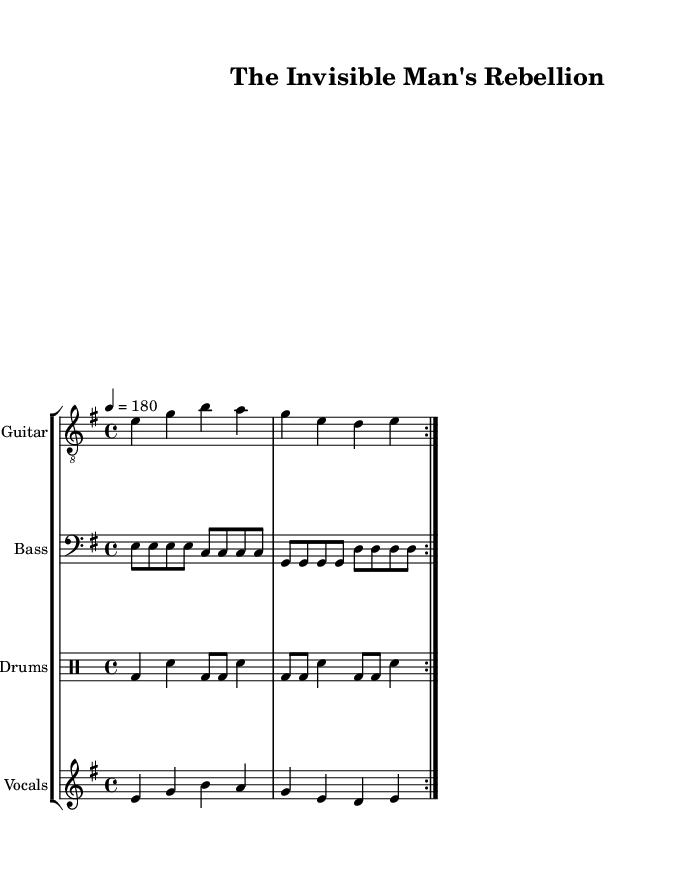What is the key signature of this music? The key signature is E minor, which has one sharp (F#). This is determined by looking at the beginning of the music sheet where the key is indicated.
Answer: E minor What is the time signature of this music? The time signature is 4/4, as indicated at the start of the music sheet. This means there are four beats in each measure, and each quarter note gets one beat.
Answer: 4/4 What is the tempo marking for this piece? The tempo marking is 180 BPM as specified in the tempo indication at the beginning of the music. BPM stands for beats per minute, indicating the speed of the music.
Answer: 180 How many measures are repeated in the song? The song has 2 measures repeated, as indicated by the repeat signs which show that the section should be played twice.
Answer: 2 What is the vocal range indicated in the sheet music? The vocal range is within an octave, starting from E to the high note A in the melody of the vocals, covering notes that fit within a major scale.
Answer: E to A What literary theme does the song title reference? The song title "The Invisible Man's Rebellion" references the theme of isolation and struggle, which is central to H.G. Wells' novel "The Invisible Man," linking literature to the song's punk ethos.
Answer: Isolation and struggle 